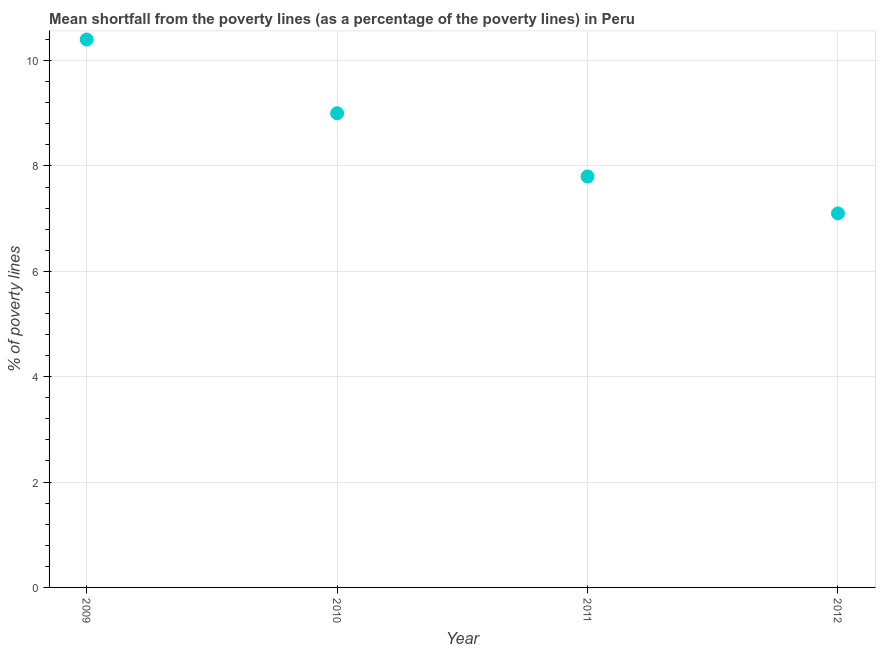What is the poverty gap at national poverty lines in 2009?
Your answer should be very brief. 10.4. Across all years, what is the minimum poverty gap at national poverty lines?
Your answer should be very brief. 7.1. In which year was the poverty gap at national poverty lines minimum?
Offer a terse response. 2012. What is the sum of the poverty gap at national poverty lines?
Offer a very short reply. 34.3. What is the difference between the poverty gap at national poverty lines in 2009 and 2012?
Offer a terse response. 3.3. What is the average poverty gap at national poverty lines per year?
Ensure brevity in your answer.  8.57. What is the median poverty gap at national poverty lines?
Provide a short and direct response. 8.4. What is the ratio of the poverty gap at national poverty lines in 2009 to that in 2012?
Your answer should be very brief. 1.46. Is the difference between the poverty gap at national poverty lines in 2009 and 2011 greater than the difference between any two years?
Your answer should be very brief. No. What is the difference between the highest and the second highest poverty gap at national poverty lines?
Provide a short and direct response. 1.4. What is the difference between the highest and the lowest poverty gap at national poverty lines?
Your answer should be very brief. 3.3. In how many years, is the poverty gap at national poverty lines greater than the average poverty gap at national poverty lines taken over all years?
Keep it short and to the point. 2. How many dotlines are there?
Provide a succinct answer. 1. How many years are there in the graph?
Provide a succinct answer. 4. What is the difference between two consecutive major ticks on the Y-axis?
Provide a succinct answer. 2. Are the values on the major ticks of Y-axis written in scientific E-notation?
Offer a terse response. No. Does the graph contain any zero values?
Your answer should be very brief. No. Does the graph contain grids?
Offer a terse response. Yes. What is the title of the graph?
Your response must be concise. Mean shortfall from the poverty lines (as a percentage of the poverty lines) in Peru. What is the label or title of the Y-axis?
Ensure brevity in your answer.  % of poverty lines. What is the % of poverty lines in 2009?
Your response must be concise. 10.4. What is the % of poverty lines in 2010?
Provide a succinct answer. 9. What is the % of poverty lines in 2012?
Make the answer very short. 7.1. What is the difference between the % of poverty lines in 2009 and 2011?
Offer a very short reply. 2.6. What is the difference between the % of poverty lines in 2010 and 2011?
Your answer should be compact. 1.2. What is the difference between the % of poverty lines in 2010 and 2012?
Keep it short and to the point. 1.9. What is the difference between the % of poverty lines in 2011 and 2012?
Keep it short and to the point. 0.7. What is the ratio of the % of poverty lines in 2009 to that in 2010?
Your response must be concise. 1.16. What is the ratio of the % of poverty lines in 2009 to that in 2011?
Offer a very short reply. 1.33. What is the ratio of the % of poverty lines in 2009 to that in 2012?
Keep it short and to the point. 1.47. What is the ratio of the % of poverty lines in 2010 to that in 2011?
Your answer should be very brief. 1.15. What is the ratio of the % of poverty lines in 2010 to that in 2012?
Provide a short and direct response. 1.27. What is the ratio of the % of poverty lines in 2011 to that in 2012?
Ensure brevity in your answer.  1.1. 